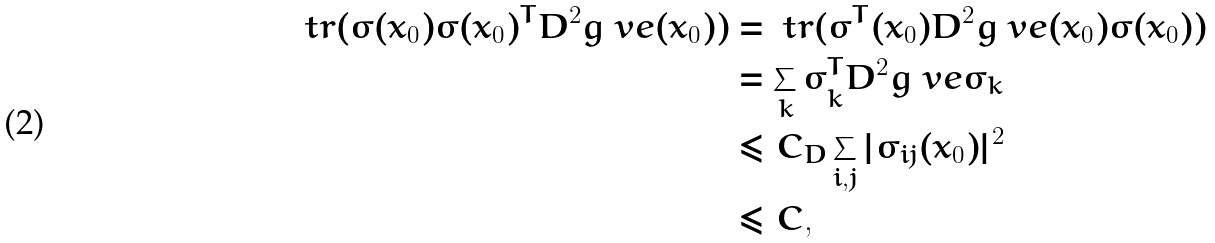Convert formula to latex. <formula><loc_0><loc_0><loc_500><loc_500>\ t r ( \sigma ( x _ { 0 } ) \sigma ( x _ { 0 } ) ^ { T } D ^ { 2 } g ^ { \ } v e ( x _ { 0 } ) ) & = \ t r ( \sigma ^ { T } ( x _ { 0 } ) D ^ { 2 } g ^ { \ } v e ( x _ { 0 } ) \sigma ( x _ { 0 } ) ) \\ & = \sum _ { k } \sigma _ { k } ^ { T } D ^ { 2 } g ^ { \ } v e \sigma _ { k } \\ & \leq C _ { D } \sum _ { i , j } | \sigma _ { i j } ( x _ { 0 } ) | ^ { 2 } \\ & \leq C ,</formula> 